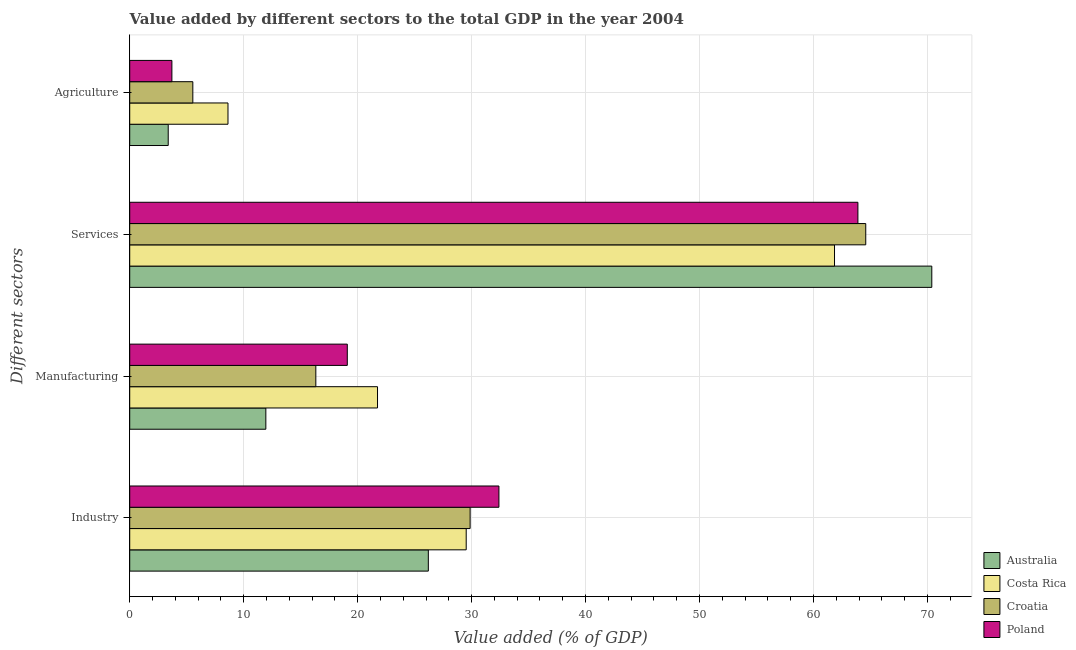How many different coloured bars are there?
Give a very brief answer. 4. How many groups of bars are there?
Provide a short and direct response. 4. What is the label of the 4th group of bars from the top?
Provide a short and direct response. Industry. What is the value added by agricultural sector in Croatia?
Your response must be concise. 5.54. Across all countries, what is the maximum value added by manufacturing sector?
Your answer should be compact. 21.74. Across all countries, what is the minimum value added by industrial sector?
Keep it short and to the point. 26.2. In which country was the value added by industrial sector maximum?
Your answer should be very brief. Poland. In which country was the value added by agricultural sector minimum?
Make the answer very short. Australia. What is the total value added by manufacturing sector in the graph?
Give a very brief answer. 69.11. What is the difference between the value added by manufacturing sector in Croatia and that in Costa Rica?
Offer a very short reply. -5.41. What is the difference between the value added by industrial sector in Costa Rica and the value added by services sector in Croatia?
Provide a short and direct response. -35.06. What is the average value added by manufacturing sector per country?
Provide a short and direct response. 17.28. What is the difference between the value added by agricultural sector and value added by services sector in Croatia?
Your response must be concise. -59.05. What is the ratio of the value added by services sector in Poland to that in Australia?
Give a very brief answer. 0.91. What is the difference between the highest and the second highest value added by services sector?
Offer a terse response. 5.8. What is the difference between the highest and the lowest value added by industrial sector?
Offer a very short reply. 6.19. In how many countries, is the value added by agricultural sector greater than the average value added by agricultural sector taken over all countries?
Make the answer very short. 2. Is the sum of the value added by manufacturing sector in Croatia and Poland greater than the maximum value added by agricultural sector across all countries?
Provide a succinct answer. Yes. What does the 2nd bar from the top in Services represents?
Provide a succinct answer. Croatia. Is it the case that in every country, the sum of the value added by industrial sector and value added by manufacturing sector is greater than the value added by services sector?
Give a very brief answer. No. Are all the bars in the graph horizontal?
Provide a succinct answer. Yes. What is the difference between two consecutive major ticks on the X-axis?
Keep it short and to the point. 10. Does the graph contain any zero values?
Your answer should be compact. No. Does the graph contain grids?
Your answer should be compact. Yes. How many legend labels are there?
Offer a very short reply. 4. How are the legend labels stacked?
Make the answer very short. Vertical. What is the title of the graph?
Your response must be concise. Value added by different sectors to the total GDP in the year 2004. Does "Andorra" appear as one of the legend labels in the graph?
Provide a short and direct response. No. What is the label or title of the X-axis?
Make the answer very short. Value added (% of GDP). What is the label or title of the Y-axis?
Your response must be concise. Different sectors. What is the Value added (% of GDP) in Australia in Industry?
Provide a short and direct response. 26.2. What is the Value added (% of GDP) in Costa Rica in Industry?
Your answer should be very brief. 29.53. What is the Value added (% of GDP) of Croatia in Industry?
Your answer should be compact. 29.87. What is the Value added (% of GDP) of Poland in Industry?
Offer a very short reply. 32.4. What is the Value added (% of GDP) of Australia in Manufacturing?
Your answer should be compact. 11.94. What is the Value added (% of GDP) of Costa Rica in Manufacturing?
Give a very brief answer. 21.74. What is the Value added (% of GDP) of Croatia in Manufacturing?
Offer a terse response. 16.33. What is the Value added (% of GDP) of Poland in Manufacturing?
Offer a very short reply. 19.09. What is the Value added (% of GDP) in Australia in Services?
Make the answer very short. 70.39. What is the Value added (% of GDP) of Costa Rica in Services?
Offer a very short reply. 61.85. What is the Value added (% of GDP) in Croatia in Services?
Offer a terse response. 64.59. What is the Value added (% of GDP) of Poland in Services?
Keep it short and to the point. 63.9. What is the Value added (% of GDP) in Australia in Agriculture?
Provide a succinct answer. 3.38. What is the Value added (% of GDP) of Costa Rica in Agriculture?
Keep it short and to the point. 8.62. What is the Value added (% of GDP) of Croatia in Agriculture?
Keep it short and to the point. 5.54. What is the Value added (% of GDP) in Poland in Agriculture?
Your answer should be very brief. 3.7. Across all Different sectors, what is the maximum Value added (% of GDP) of Australia?
Provide a short and direct response. 70.39. Across all Different sectors, what is the maximum Value added (% of GDP) in Costa Rica?
Provide a succinct answer. 61.85. Across all Different sectors, what is the maximum Value added (% of GDP) of Croatia?
Make the answer very short. 64.59. Across all Different sectors, what is the maximum Value added (% of GDP) in Poland?
Your answer should be very brief. 63.9. Across all Different sectors, what is the minimum Value added (% of GDP) of Australia?
Offer a very short reply. 3.38. Across all Different sectors, what is the minimum Value added (% of GDP) of Costa Rica?
Ensure brevity in your answer.  8.62. Across all Different sectors, what is the minimum Value added (% of GDP) in Croatia?
Ensure brevity in your answer.  5.54. Across all Different sectors, what is the minimum Value added (% of GDP) of Poland?
Offer a terse response. 3.7. What is the total Value added (% of GDP) of Australia in the graph?
Your answer should be compact. 111.91. What is the total Value added (% of GDP) of Costa Rica in the graph?
Your answer should be very brief. 121.74. What is the total Value added (% of GDP) in Croatia in the graph?
Keep it short and to the point. 116.33. What is the total Value added (% of GDP) in Poland in the graph?
Offer a very short reply. 119.09. What is the difference between the Value added (% of GDP) in Australia in Industry and that in Manufacturing?
Keep it short and to the point. 14.26. What is the difference between the Value added (% of GDP) of Costa Rica in Industry and that in Manufacturing?
Provide a short and direct response. 7.78. What is the difference between the Value added (% of GDP) in Croatia in Industry and that in Manufacturing?
Provide a succinct answer. 13.54. What is the difference between the Value added (% of GDP) in Poland in Industry and that in Manufacturing?
Give a very brief answer. 13.31. What is the difference between the Value added (% of GDP) of Australia in Industry and that in Services?
Offer a terse response. -44.18. What is the difference between the Value added (% of GDP) of Costa Rica in Industry and that in Services?
Your response must be concise. -32.32. What is the difference between the Value added (% of GDP) of Croatia in Industry and that in Services?
Make the answer very short. -34.72. What is the difference between the Value added (% of GDP) in Poland in Industry and that in Services?
Make the answer very short. -31.5. What is the difference between the Value added (% of GDP) in Australia in Industry and that in Agriculture?
Keep it short and to the point. 22.83. What is the difference between the Value added (% of GDP) in Costa Rica in Industry and that in Agriculture?
Keep it short and to the point. 20.9. What is the difference between the Value added (% of GDP) in Croatia in Industry and that in Agriculture?
Offer a very short reply. 24.34. What is the difference between the Value added (% of GDP) in Poland in Industry and that in Agriculture?
Your answer should be very brief. 28.7. What is the difference between the Value added (% of GDP) in Australia in Manufacturing and that in Services?
Offer a terse response. -58.44. What is the difference between the Value added (% of GDP) of Costa Rica in Manufacturing and that in Services?
Make the answer very short. -40.1. What is the difference between the Value added (% of GDP) in Croatia in Manufacturing and that in Services?
Your response must be concise. -48.26. What is the difference between the Value added (% of GDP) of Poland in Manufacturing and that in Services?
Your response must be concise. -44.81. What is the difference between the Value added (% of GDP) in Australia in Manufacturing and that in Agriculture?
Offer a terse response. 8.57. What is the difference between the Value added (% of GDP) of Costa Rica in Manufacturing and that in Agriculture?
Ensure brevity in your answer.  13.12. What is the difference between the Value added (% of GDP) of Croatia in Manufacturing and that in Agriculture?
Offer a very short reply. 10.79. What is the difference between the Value added (% of GDP) in Poland in Manufacturing and that in Agriculture?
Provide a short and direct response. 15.39. What is the difference between the Value added (% of GDP) in Australia in Services and that in Agriculture?
Offer a terse response. 67.01. What is the difference between the Value added (% of GDP) of Costa Rica in Services and that in Agriculture?
Keep it short and to the point. 53.23. What is the difference between the Value added (% of GDP) of Croatia in Services and that in Agriculture?
Keep it short and to the point. 59.05. What is the difference between the Value added (% of GDP) in Poland in Services and that in Agriculture?
Keep it short and to the point. 60.2. What is the difference between the Value added (% of GDP) of Australia in Industry and the Value added (% of GDP) of Costa Rica in Manufacturing?
Ensure brevity in your answer.  4.46. What is the difference between the Value added (% of GDP) of Australia in Industry and the Value added (% of GDP) of Croatia in Manufacturing?
Ensure brevity in your answer.  9.87. What is the difference between the Value added (% of GDP) of Australia in Industry and the Value added (% of GDP) of Poland in Manufacturing?
Your response must be concise. 7.11. What is the difference between the Value added (% of GDP) of Costa Rica in Industry and the Value added (% of GDP) of Croatia in Manufacturing?
Your response must be concise. 13.2. What is the difference between the Value added (% of GDP) in Costa Rica in Industry and the Value added (% of GDP) in Poland in Manufacturing?
Make the answer very short. 10.43. What is the difference between the Value added (% of GDP) in Croatia in Industry and the Value added (% of GDP) in Poland in Manufacturing?
Make the answer very short. 10.78. What is the difference between the Value added (% of GDP) of Australia in Industry and the Value added (% of GDP) of Costa Rica in Services?
Offer a very short reply. -35.64. What is the difference between the Value added (% of GDP) in Australia in Industry and the Value added (% of GDP) in Croatia in Services?
Your answer should be very brief. -38.39. What is the difference between the Value added (% of GDP) of Australia in Industry and the Value added (% of GDP) of Poland in Services?
Make the answer very short. -37.7. What is the difference between the Value added (% of GDP) of Costa Rica in Industry and the Value added (% of GDP) of Croatia in Services?
Provide a succinct answer. -35.06. What is the difference between the Value added (% of GDP) in Costa Rica in Industry and the Value added (% of GDP) in Poland in Services?
Offer a terse response. -34.37. What is the difference between the Value added (% of GDP) of Croatia in Industry and the Value added (% of GDP) of Poland in Services?
Offer a terse response. -34.03. What is the difference between the Value added (% of GDP) in Australia in Industry and the Value added (% of GDP) in Costa Rica in Agriculture?
Provide a succinct answer. 17.58. What is the difference between the Value added (% of GDP) of Australia in Industry and the Value added (% of GDP) of Croatia in Agriculture?
Ensure brevity in your answer.  20.67. What is the difference between the Value added (% of GDP) in Australia in Industry and the Value added (% of GDP) in Poland in Agriculture?
Provide a succinct answer. 22.5. What is the difference between the Value added (% of GDP) in Costa Rica in Industry and the Value added (% of GDP) in Croatia in Agriculture?
Give a very brief answer. 23.99. What is the difference between the Value added (% of GDP) of Costa Rica in Industry and the Value added (% of GDP) of Poland in Agriculture?
Offer a terse response. 25.83. What is the difference between the Value added (% of GDP) in Croatia in Industry and the Value added (% of GDP) in Poland in Agriculture?
Make the answer very short. 26.17. What is the difference between the Value added (% of GDP) in Australia in Manufacturing and the Value added (% of GDP) in Costa Rica in Services?
Provide a succinct answer. -49.9. What is the difference between the Value added (% of GDP) of Australia in Manufacturing and the Value added (% of GDP) of Croatia in Services?
Your answer should be very brief. -52.65. What is the difference between the Value added (% of GDP) in Australia in Manufacturing and the Value added (% of GDP) in Poland in Services?
Make the answer very short. -51.96. What is the difference between the Value added (% of GDP) of Costa Rica in Manufacturing and the Value added (% of GDP) of Croatia in Services?
Provide a short and direct response. -42.85. What is the difference between the Value added (% of GDP) in Costa Rica in Manufacturing and the Value added (% of GDP) in Poland in Services?
Give a very brief answer. -42.16. What is the difference between the Value added (% of GDP) in Croatia in Manufacturing and the Value added (% of GDP) in Poland in Services?
Keep it short and to the point. -47.57. What is the difference between the Value added (% of GDP) of Australia in Manufacturing and the Value added (% of GDP) of Costa Rica in Agriculture?
Your response must be concise. 3.32. What is the difference between the Value added (% of GDP) of Australia in Manufacturing and the Value added (% of GDP) of Croatia in Agriculture?
Keep it short and to the point. 6.41. What is the difference between the Value added (% of GDP) in Australia in Manufacturing and the Value added (% of GDP) in Poland in Agriculture?
Make the answer very short. 8.25. What is the difference between the Value added (% of GDP) of Costa Rica in Manufacturing and the Value added (% of GDP) of Croatia in Agriculture?
Provide a short and direct response. 16.21. What is the difference between the Value added (% of GDP) in Costa Rica in Manufacturing and the Value added (% of GDP) in Poland in Agriculture?
Make the answer very short. 18.05. What is the difference between the Value added (% of GDP) of Croatia in Manufacturing and the Value added (% of GDP) of Poland in Agriculture?
Your answer should be very brief. 12.63. What is the difference between the Value added (% of GDP) in Australia in Services and the Value added (% of GDP) in Costa Rica in Agriculture?
Make the answer very short. 61.76. What is the difference between the Value added (% of GDP) of Australia in Services and the Value added (% of GDP) of Croatia in Agriculture?
Your response must be concise. 64.85. What is the difference between the Value added (% of GDP) in Australia in Services and the Value added (% of GDP) in Poland in Agriculture?
Provide a succinct answer. 66.69. What is the difference between the Value added (% of GDP) of Costa Rica in Services and the Value added (% of GDP) of Croatia in Agriculture?
Your answer should be very brief. 56.31. What is the difference between the Value added (% of GDP) of Costa Rica in Services and the Value added (% of GDP) of Poland in Agriculture?
Offer a terse response. 58.15. What is the difference between the Value added (% of GDP) of Croatia in Services and the Value added (% of GDP) of Poland in Agriculture?
Provide a succinct answer. 60.89. What is the average Value added (% of GDP) of Australia per Different sectors?
Your answer should be compact. 27.98. What is the average Value added (% of GDP) in Costa Rica per Different sectors?
Make the answer very short. 30.44. What is the average Value added (% of GDP) of Croatia per Different sectors?
Keep it short and to the point. 29.08. What is the average Value added (% of GDP) in Poland per Different sectors?
Offer a terse response. 29.77. What is the difference between the Value added (% of GDP) in Australia and Value added (% of GDP) in Costa Rica in Industry?
Provide a short and direct response. -3.32. What is the difference between the Value added (% of GDP) of Australia and Value added (% of GDP) of Croatia in Industry?
Offer a terse response. -3.67. What is the difference between the Value added (% of GDP) of Australia and Value added (% of GDP) of Poland in Industry?
Offer a terse response. -6.19. What is the difference between the Value added (% of GDP) in Costa Rica and Value added (% of GDP) in Croatia in Industry?
Offer a very short reply. -0.34. What is the difference between the Value added (% of GDP) in Costa Rica and Value added (% of GDP) in Poland in Industry?
Your response must be concise. -2.87. What is the difference between the Value added (% of GDP) in Croatia and Value added (% of GDP) in Poland in Industry?
Offer a terse response. -2.53. What is the difference between the Value added (% of GDP) of Australia and Value added (% of GDP) of Croatia in Manufacturing?
Keep it short and to the point. -4.39. What is the difference between the Value added (% of GDP) in Australia and Value added (% of GDP) in Poland in Manufacturing?
Keep it short and to the point. -7.15. What is the difference between the Value added (% of GDP) in Costa Rica and Value added (% of GDP) in Croatia in Manufacturing?
Offer a very short reply. 5.41. What is the difference between the Value added (% of GDP) of Costa Rica and Value added (% of GDP) of Poland in Manufacturing?
Provide a short and direct response. 2.65. What is the difference between the Value added (% of GDP) in Croatia and Value added (% of GDP) in Poland in Manufacturing?
Provide a short and direct response. -2.76. What is the difference between the Value added (% of GDP) in Australia and Value added (% of GDP) in Costa Rica in Services?
Make the answer very short. 8.54. What is the difference between the Value added (% of GDP) in Australia and Value added (% of GDP) in Croatia in Services?
Give a very brief answer. 5.8. What is the difference between the Value added (% of GDP) in Australia and Value added (% of GDP) in Poland in Services?
Ensure brevity in your answer.  6.48. What is the difference between the Value added (% of GDP) in Costa Rica and Value added (% of GDP) in Croatia in Services?
Make the answer very short. -2.74. What is the difference between the Value added (% of GDP) of Costa Rica and Value added (% of GDP) of Poland in Services?
Provide a succinct answer. -2.05. What is the difference between the Value added (% of GDP) in Croatia and Value added (% of GDP) in Poland in Services?
Your answer should be compact. 0.69. What is the difference between the Value added (% of GDP) of Australia and Value added (% of GDP) of Costa Rica in Agriculture?
Provide a succinct answer. -5.25. What is the difference between the Value added (% of GDP) in Australia and Value added (% of GDP) in Croatia in Agriculture?
Offer a terse response. -2.16. What is the difference between the Value added (% of GDP) of Australia and Value added (% of GDP) of Poland in Agriculture?
Your answer should be very brief. -0.32. What is the difference between the Value added (% of GDP) of Costa Rica and Value added (% of GDP) of Croatia in Agriculture?
Your answer should be very brief. 3.09. What is the difference between the Value added (% of GDP) of Costa Rica and Value added (% of GDP) of Poland in Agriculture?
Keep it short and to the point. 4.92. What is the difference between the Value added (% of GDP) of Croatia and Value added (% of GDP) of Poland in Agriculture?
Offer a very short reply. 1.84. What is the ratio of the Value added (% of GDP) in Australia in Industry to that in Manufacturing?
Make the answer very short. 2.19. What is the ratio of the Value added (% of GDP) of Costa Rica in Industry to that in Manufacturing?
Make the answer very short. 1.36. What is the ratio of the Value added (% of GDP) in Croatia in Industry to that in Manufacturing?
Provide a short and direct response. 1.83. What is the ratio of the Value added (% of GDP) of Poland in Industry to that in Manufacturing?
Provide a succinct answer. 1.7. What is the ratio of the Value added (% of GDP) of Australia in Industry to that in Services?
Provide a short and direct response. 0.37. What is the ratio of the Value added (% of GDP) of Costa Rica in Industry to that in Services?
Your response must be concise. 0.48. What is the ratio of the Value added (% of GDP) of Croatia in Industry to that in Services?
Offer a terse response. 0.46. What is the ratio of the Value added (% of GDP) of Poland in Industry to that in Services?
Provide a short and direct response. 0.51. What is the ratio of the Value added (% of GDP) in Australia in Industry to that in Agriculture?
Provide a short and direct response. 7.76. What is the ratio of the Value added (% of GDP) in Costa Rica in Industry to that in Agriculture?
Your response must be concise. 3.42. What is the ratio of the Value added (% of GDP) of Croatia in Industry to that in Agriculture?
Offer a terse response. 5.4. What is the ratio of the Value added (% of GDP) of Poland in Industry to that in Agriculture?
Offer a terse response. 8.76. What is the ratio of the Value added (% of GDP) in Australia in Manufacturing to that in Services?
Your answer should be compact. 0.17. What is the ratio of the Value added (% of GDP) of Costa Rica in Manufacturing to that in Services?
Give a very brief answer. 0.35. What is the ratio of the Value added (% of GDP) of Croatia in Manufacturing to that in Services?
Offer a terse response. 0.25. What is the ratio of the Value added (% of GDP) in Poland in Manufacturing to that in Services?
Provide a succinct answer. 0.3. What is the ratio of the Value added (% of GDP) in Australia in Manufacturing to that in Agriculture?
Provide a short and direct response. 3.54. What is the ratio of the Value added (% of GDP) of Costa Rica in Manufacturing to that in Agriculture?
Your answer should be very brief. 2.52. What is the ratio of the Value added (% of GDP) in Croatia in Manufacturing to that in Agriculture?
Keep it short and to the point. 2.95. What is the ratio of the Value added (% of GDP) of Poland in Manufacturing to that in Agriculture?
Your answer should be compact. 5.16. What is the ratio of the Value added (% of GDP) of Australia in Services to that in Agriculture?
Your response must be concise. 20.83. What is the ratio of the Value added (% of GDP) in Costa Rica in Services to that in Agriculture?
Make the answer very short. 7.17. What is the ratio of the Value added (% of GDP) of Croatia in Services to that in Agriculture?
Make the answer very short. 11.67. What is the ratio of the Value added (% of GDP) of Poland in Services to that in Agriculture?
Make the answer very short. 17.27. What is the difference between the highest and the second highest Value added (% of GDP) in Australia?
Ensure brevity in your answer.  44.18. What is the difference between the highest and the second highest Value added (% of GDP) in Costa Rica?
Make the answer very short. 32.32. What is the difference between the highest and the second highest Value added (% of GDP) of Croatia?
Keep it short and to the point. 34.72. What is the difference between the highest and the second highest Value added (% of GDP) of Poland?
Offer a very short reply. 31.5. What is the difference between the highest and the lowest Value added (% of GDP) in Australia?
Provide a short and direct response. 67.01. What is the difference between the highest and the lowest Value added (% of GDP) of Costa Rica?
Make the answer very short. 53.23. What is the difference between the highest and the lowest Value added (% of GDP) in Croatia?
Offer a terse response. 59.05. What is the difference between the highest and the lowest Value added (% of GDP) in Poland?
Ensure brevity in your answer.  60.2. 